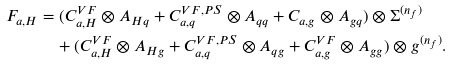<formula> <loc_0><loc_0><loc_500><loc_500>F _ { a , H } & = ( C _ { a , H } ^ { V F } \otimes A _ { H q } + C _ { a , q } ^ { V F , P S } \otimes A _ { q q } + C _ { a , g } \otimes A _ { g q } ) \otimes \Sigma ^ { ( n _ { f } ) } \\ & \quad + ( C _ { a , H } ^ { V F } \otimes A _ { H g } + C _ { a , q } ^ { V F , P S } \otimes A _ { q g } + C _ { a , g } ^ { V F } \otimes A _ { g g } ) \otimes g ^ { ( n _ { f } ) } .</formula> 